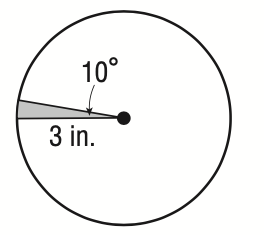Answer the mathemtical geometry problem and directly provide the correct option letter.
Question: What is the area of the sector?
Choices: A: \frac { \pi } { 6 } B: \frac { \pi } { 4 } C: \frac { 3 \pi } { 5 } D: \frac { 9 \pi } { 10 } B 